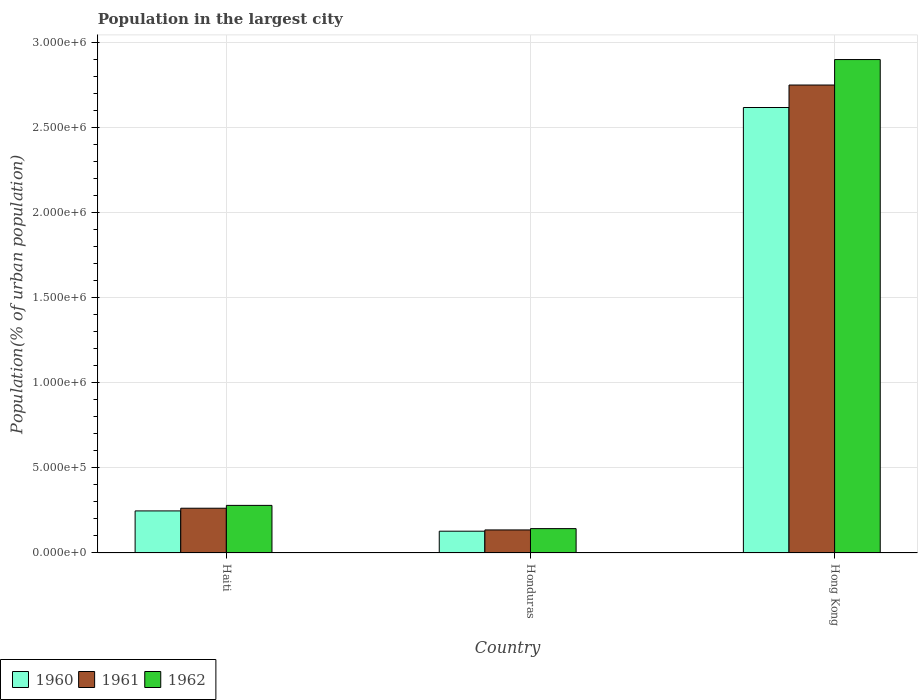How many groups of bars are there?
Ensure brevity in your answer.  3. Are the number of bars on each tick of the X-axis equal?
Your answer should be compact. Yes. How many bars are there on the 3rd tick from the right?
Your answer should be very brief. 3. What is the label of the 2nd group of bars from the left?
Your answer should be compact. Honduras. What is the population in the largest city in 1961 in Honduras?
Offer a terse response. 1.36e+05. Across all countries, what is the maximum population in the largest city in 1962?
Your response must be concise. 2.90e+06. Across all countries, what is the minimum population in the largest city in 1961?
Offer a terse response. 1.36e+05. In which country was the population in the largest city in 1960 maximum?
Provide a succinct answer. Hong Kong. In which country was the population in the largest city in 1962 minimum?
Your response must be concise. Honduras. What is the total population in the largest city in 1962 in the graph?
Offer a very short reply. 3.33e+06. What is the difference between the population in the largest city in 1960 in Haiti and that in Honduras?
Make the answer very short. 1.19e+05. What is the difference between the population in the largest city in 1961 in Hong Kong and the population in the largest city in 1960 in Haiti?
Offer a terse response. 2.51e+06. What is the average population in the largest city in 1960 per country?
Give a very brief answer. 9.99e+05. What is the difference between the population in the largest city of/in 1962 and population in the largest city of/in 1960 in Haiti?
Offer a very short reply. 3.26e+04. What is the ratio of the population in the largest city in 1960 in Honduras to that in Hong Kong?
Provide a short and direct response. 0.05. Is the difference between the population in the largest city in 1962 in Honduras and Hong Kong greater than the difference between the population in the largest city in 1960 in Honduras and Hong Kong?
Offer a very short reply. No. What is the difference between the highest and the second highest population in the largest city in 1960?
Keep it short and to the point. 2.49e+06. What is the difference between the highest and the lowest population in the largest city in 1962?
Offer a very short reply. 2.76e+06. Is the sum of the population in the largest city in 1960 in Haiti and Hong Kong greater than the maximum population in the largest city in 1962 across all countries?
Your answer should be compact. No. What does the 3rd bar from the left in Hong Kong represents?
Ensure brevity in your answer.  1962. What does the 2nd bar from the right in Honduras represents?
Offer a very short reply. 1961. How many bars are there?
Provide a short and direct response. 9. Are all the bars in the graph horizontal?
Give a very brief answer. No. What is the difference between two consecutive major ticks on the Y-axis?
Offer a very short reply. 5.00e+05. Are the values on the major ticks of Y-axis written in scientific E-notation?
Your response must be concise. Yes. Does the graph contain any zero values?
Make the answer very short. No. How are the legend labels stacked?
Ensure brevity in your answer.  Horizontal. What is the title of the graph?
Offer a terse response. Population in the largest city. Does "1988" appear as one of the legend labels in the graph?
Provide a succinct answer. No. What is the label or title of the X-axis?
Your answer should be compact. Country. What is the label or title of the Y-axis?
Offer a very short reply. Population(% of urban population). What is the Population(% of urban population) in 1960 in Haiti?
Provide a succinct answer. 2.47e+05. What is the Population(% of urban population) of 1961 in Haiti?
Make the answer very short. 2.63e+05. What is the Population(% of urban population) in 1962 in Haiti?
Offer a very short reply. 2.80e+05. What is the Population(% of urban population) of 1960 in Honduras?
Provide a succinct answer. 1.28e+05. What is the Population(% of urban population) in 1961 in Honduras?
Provide a short and direct response. 1.36e+05. What is the Population(% of urban population) of 1962 in Honduras?
Keep it short and to the point. 1.43e+05. What is the Population(% of urban population) of 1960 in Hong Kong?
Your answer should be very brief. 2.62e+06. What is the Population(% of urban population) in 1961 in Hong Kong?
Your answer should be compact. 2.75e+06. What is the Population(% of urban population) in 1962 in Hong Kong?
Keep it short and to the point. 2.90e+06. Across all countries, what is the maximum Population(% of urban population) of 1960?
Give a very brief answer. 2.62e+06. Across all countries, what is the maximum Population(% of urban population) in 1961?
Provide a short and direct response. 2.75e+06. Across all countries, what is the maximum Population(% of urban population) in 1962?
Give a very brief answer. 2.90e+06. Across all countries, what is the minimum Population(% of urban population) in 1960?
Offer a very short reply. 1.28e+05. Across all countries, what is the minimum Population(% of urban population) in 1961?
Your response must be concise. 1.36e+05. Across all countries, what is the minimum Population(% of urban population) of 1962?
Provide a succinct answer. 1.43e+05. What is the total Population(% of urban population) in 1960 in the graph?
Provide a short and direct response. 3.00e+06. What is the total Population(% of urban population) of 1961 in the graph?
Your answer should be very brief. 3.15e+06. What is the total Population(% of urban population) in 1962 in the graph?
Provide a succinct answer. 3.33e+06. What is the difference between the Population(% of urban population) of 1960 in Haiti and that in Honduras?
Your answer should be compact. 1.19e+05. What is the difference between the Population(% of urban population) of 1961 in Haiti and that in Honduras?
Ensure brevity in your answer.  1.28e+05. What is the difference between the Population(% of urban population) of 1962 in Haiti and that in Honduras?
Give a very brief answer. 1.37e+05. What is the difference between the Population(% of urban population) in 1960 in Haiti and that in Hong Kong?
Ensure brevity in your answer.  -2.37e+06. What is the difference between the Population(% of urban population) of 1961 in Haiti and that in Hong Kong?
Ensure brevity in your answer.  -2.49e+06. What is the difference between the Population(% of urban population) in 1962 in Haiti and that in Hong Kong?
Offer a terse response. -2.62e+06. What is the difference between the Population(% of urban population) in 1960 in Honduras and that in Hong Kong?
Your answer should be compact. -2.49e+06. What is the difference between the Population(% of urban population) of 1961 in Honduras and that in Hong Kong?
Provide a succinct answer. -2.62e+06. What is the difference between the Population(% of urban population) of 1962 in Honduras and that in Hong Kong?
Give a very brief answer. -2.76e+06. What is the difference between the Population(% of urban population) in 1960 in Haiti and the Population(% of urban population) in 1961 in Honduras?
Your answer should be compact. 1.12e+05. What is the difference between the Population(% of urban population) of 1960 in Haiti and the Population(% of urban population) of 1962 in Honduras?
Provide a short and direct response. 1.04e+05. What is the difference between the Population(% of urban population) of 1961 in Haiti and the Population(% of urban population) of 1962 in Honduras?
Your answer should be compact. 1.20e+05. What is the difference between the Population(% of urban population) of 1960 in Haiti and the Population(% of urban population) of 1961 in Hong Kong?
Provide a short and direct response. -2.51e+06. What is the difference between the Population(% of urban population) in 1960 in Haiti and the Population(% of urban population) in 1962 in Hong Kong?
Your answer should be compact. -2.66e+06. What is the difference between the Population(% of urban population) of 1961 in Haiti and the Population(% of urban population) of 1962 in Hong Kong?
Ensure brevity in your answer.  -2.64e+06. What is the difference between the Population(% of urban population) of 1960 in Honduras and the Population(% of urban population) of 1961 in Hong Kong?
Ensure brevity in your answer.  -2.62e+06. What is the difference between the Population(% of urban population) in 1960 in Honduras and the Population(% of urban population) in 1962 in Hong Kong?
Make the answer very short. -2.77e+06. What is the difference between the Population(% of urban population) in 1961 in Honduras and the Population(% of urban population) in 1962 in Hong Kong?
Provide a succinct answer. -2.77e+06. What is the average Population(% of urban population) of 1960 per country?
Provide a short and direct response. 9.99e+05. What is the average Population(% of urban population) in 1961 per country?
Provide a succinct answer. 1.05e+06. What is the average Population(% of urban population) in 1962 per country?
Provide a short and direct response. 1.11e+06. What is the difference between the Population(% of urban population) of 1960 and Population(% of urban population) of 1961 in Haiti?
Provide a short and direct response. -1.58e+04. What is the difference between the Population(% of urban population) in 1960 and Population(% of urban population) in 1962 in Haiti?
Make the answer very short. -3.26e+04. What is the difference between the Population(% of urban population) in 1961 and Population(% of urban population) in 1962 in Haiti?
Your answer should be compact. -1.68e+04. What is the difference between the Population(% of urban population) of 1960 and Population(% of urban population) of 1961 in Honduras?
Offer a very short reply. -7454. What is the difference between the Population(% of urban population) of 1960 and Population(% of urban population) of 1962 in Honduras?
Make the answer very short. -1.52e+04. What is the difference between the Population(% of urban population) in 1961 and Population(% of urban population) in 1962 in Honduras?
Offer a very short reply. -7731. What is the difference between the Population(% of urban population) of 1960 and Population(% of urban population) of 1961 in Hong Kong?
Your answer should be very brief. -1.32e+05. What is the difference between the Population(% of urban population) in 1960 and Population(% of urban population) in 1962 in Hong Kong?
Provide a short and direct response. -2.82e+05. What is the difference between the Population(% of urban population) of 1961 and Population(% of urban population) of 1962 in Hong Kong?
Your answer should be very brief. -1.50e+05. What is the ratio of the Population(% of urban population) in 1960 in Haiti to that in Honduras?
Give a very brief answer. 1.93. What is the ratio of the Population(% of urban population) in 1961 in Haiti to that in Honduras?
Offer a terse response. 1.94. What is the ratio of the Population(% of urban population) of 1962 in Haiti to that in Honduras?
Your response must be concise. 1.95. What is the ratio of the Population(% of urban population) of 1960 in Haiti to that in Hong Kong?
Your response must be concise. 0.09. What is the ratio of the Population(% of urban population) of 1961 in Haiti to that in Hong Kong?
Your answer should be very brief. 0.1. What is the ratio of the Population(% of urban population) in 1962 in Haiti to that in Hong Kong?
Make the answer very short. 0.1. What is the ratio of the Population(% of urban population) in 1960 in Honduras to that in Hong Kong?
Offer a very short reply. 0.05. What is the ratio of the Population(% of urban population) in 1961 in Honduras to that in Hong Kong?
Your response must be concise. 0.05. What is the ratio of the Population(% of urban population) in 1962 in Honduras to that in Hong Kong?
Offer a terse response. 0.05. What is the difference between the highest and the second highest Population(% of urban population) of 1960?
Your answer should be compact. 2.37e+06. What is the difference between the highest and the second highest Population(% of urban population) in 1961?
Provide a short and direct response. 2.49e+06. What is the difference between the highest and the second highest Population(% of urban population) of 1962?
Keep it short and to the point. 2.62e+06. What is the difference between the highest and the lowest Population(% of urban population) of 1960?
Make the answer very short. 2.49e+06. What is the difference between the highest and the lowest Population(% of urban population) in 1961?
Keep it short and to the point. 2.62e+06. What is the difference between the highest and the lowest Population(% of urban population) in 1962?
Your response must be concise. 2.76e+06. 